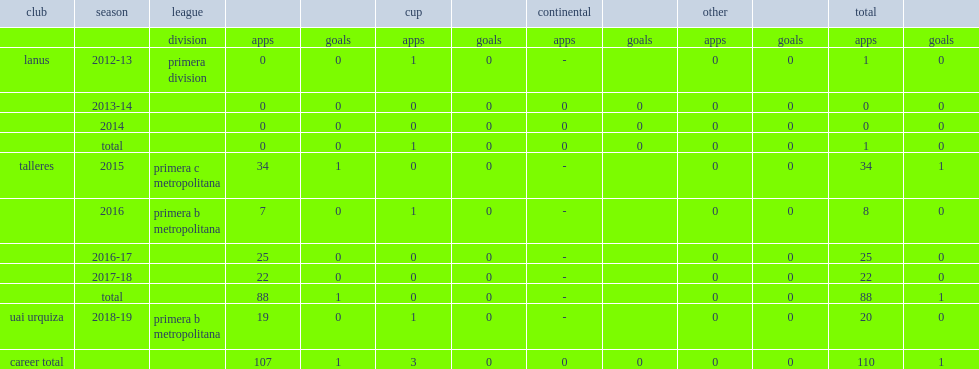In 2015, which league did borda move to talleres? Primera c metropolitana. 